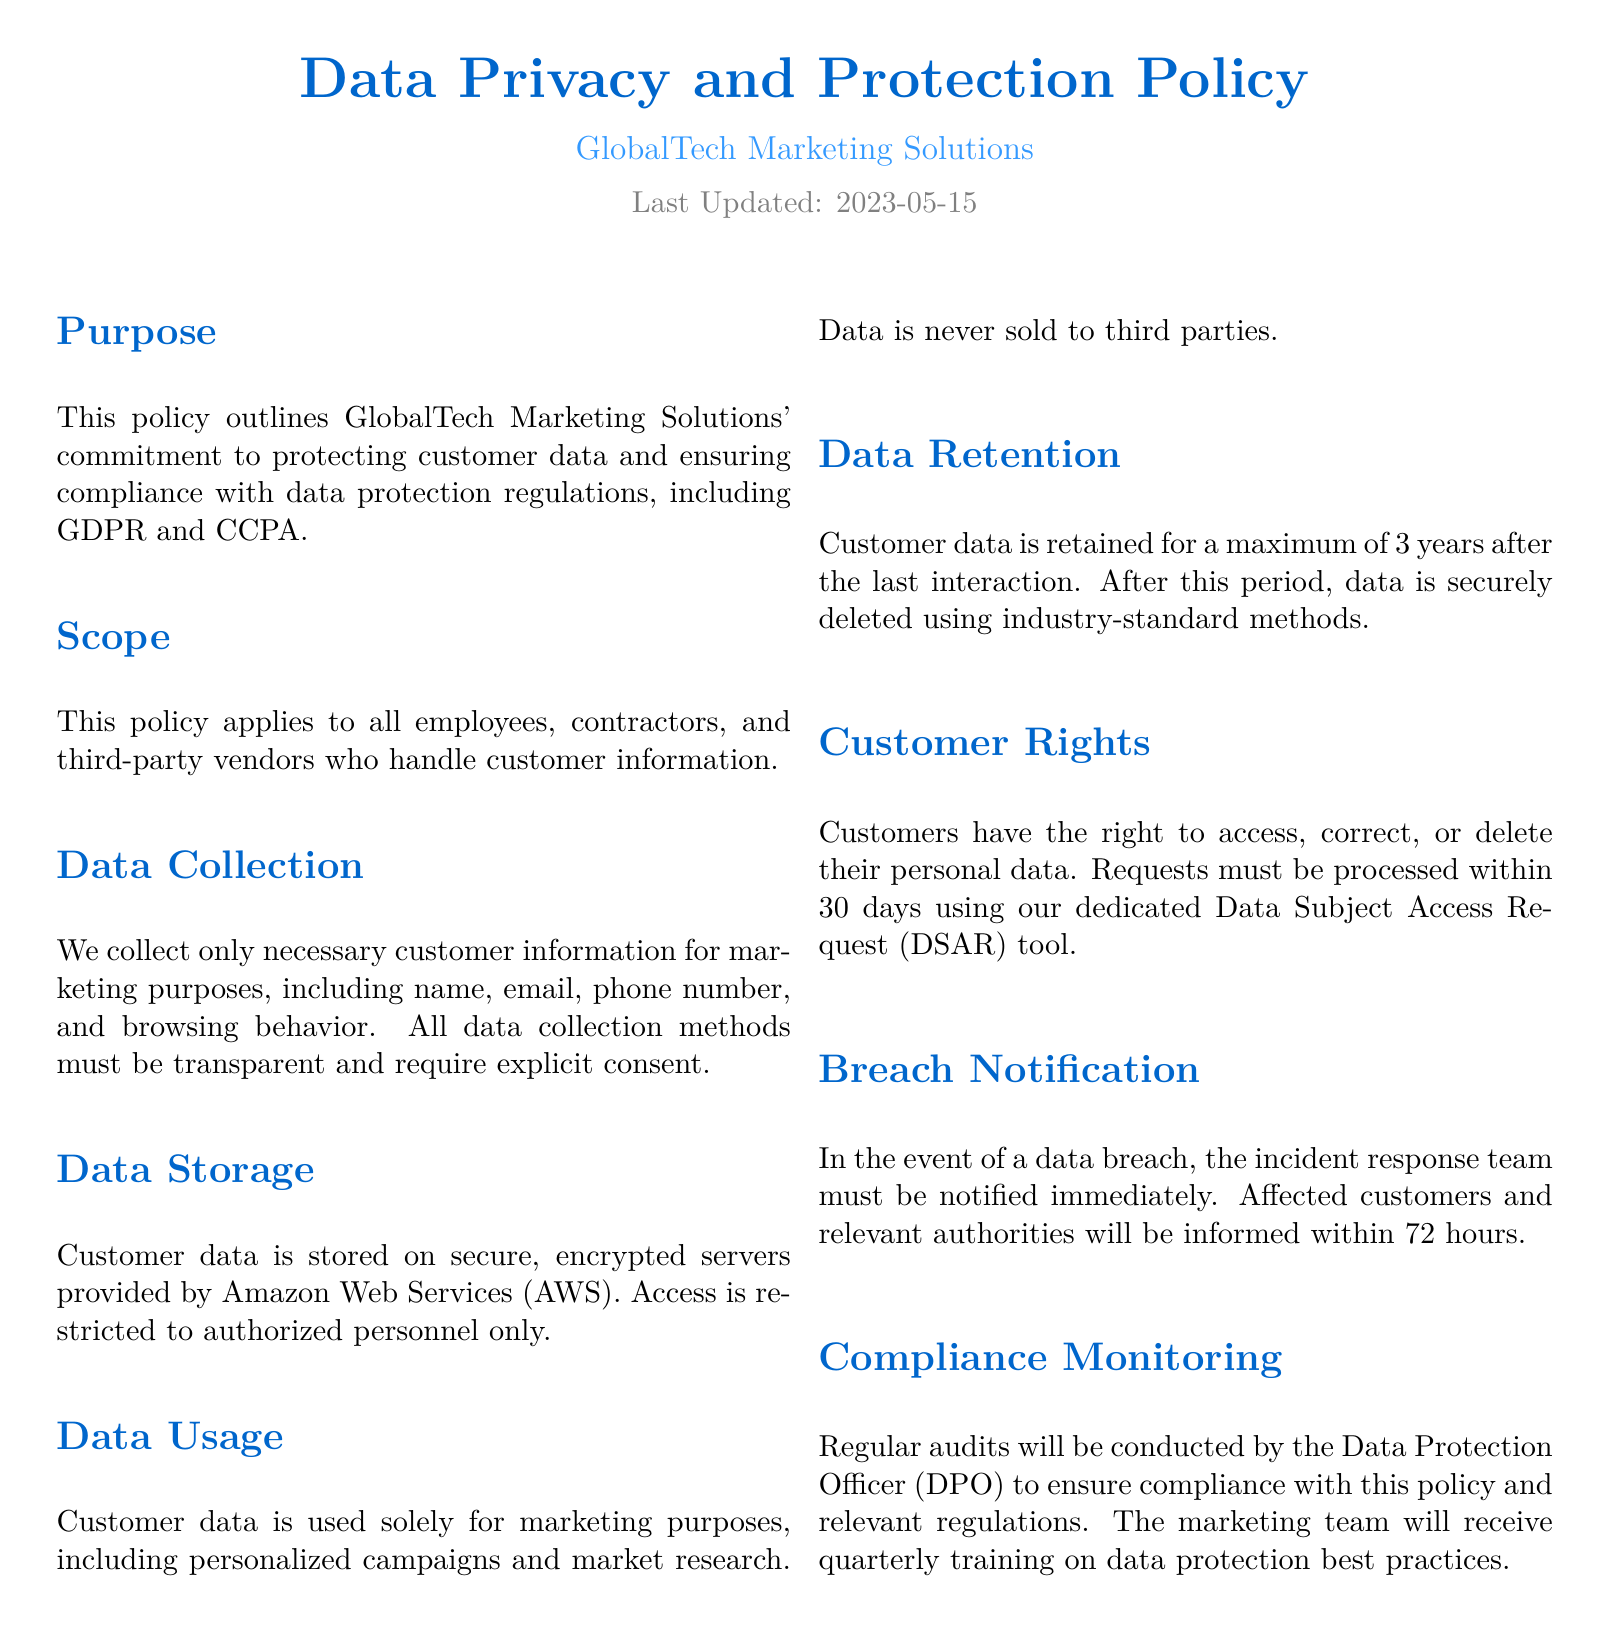What is the purpose of this policy? The purpose of the policy is to outline GlobalTech Marketing Solutions' commitment to protecting customer data and ensuring compliance with data protection regulations, including GDPR and CCPA.
Answer: Protecting customer data and ensuring compliance with data protection regulations Who is the policy applicable to? The policy states it applies to all employees, contractors, and third-party vendors who handle customer information.
Answer: Employees, contractors, and third-party vendors What customer information do we collect? The document specifies the types of information collected, which include name, email, phone number, and browsing behavior.
Answer: Name, email, phone number, and browsing behavior What is the maximum retention period for customer data? The document mentions that customer data is retained for a maximum of 3 years after the last interaction.
Answer: 3 years What is the notification period in case of a data breach? The policy states that affected customers and relevant authorities will be informed within 72 hours following a data breach.
Answer: 72 hours How often will compliance audits be conducted? According to the policy, regular audits will be conducted by the Data Protection Officer, but the frequency of the audits is not specified in detail.
Answer: Regular audits What tool is used for processing data access requests? The document mentions using a dedicated Data Subject Access Request (DSAR) tool for processing requests.
Answer: Data Subject Access Request (DSAR) tool What type of training will the marketing team receive? The policy states that the marketing team will receive quarterly training on data protection best practices.
Answer: Quarterly training on data protection best practices Is customer data ever sold to third parties? The document clearly states that data is never sold to third parties.
Answer: No 